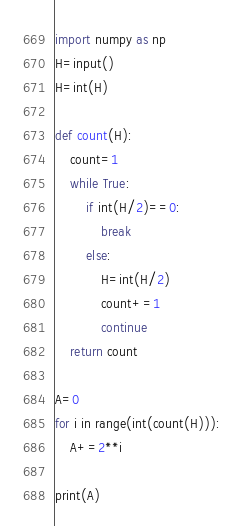Convert code to text. <code><loc_0><loc_0><loc_500><loc_500><_Python_>import numpy as np
H=input()
H=int(H)

def count(H):
	count=1
	while True:
		if int(H/2)==0:
			break
		else:
			H=int(H/2)
			count+=1
			continue
	return count

A=0
for i in range(int(count(H))):
	A+=2**i
			
print(A)</code> 